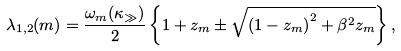Convert formula to latex. <formula><loc_0><loc_0><loc_500><loc_500>\lambda _ { 1 , 2 } ( m ) = \frac { \omega _ { m } ( \kappa _ { \gg } ) } { 2 } \left \{ 1 + z _ { m } \pm \sqrt { \left ( 1 - z _ { m } \right ) ^ { 2 } + \beta ^ { 2 } z _ { m } } \right \} ,</formula> 